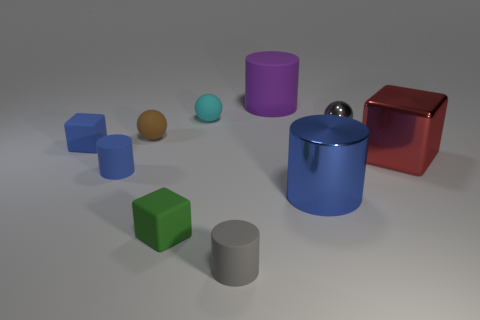What number of shiny things are brown objects or green things?
Provide a short and direct response. 0. There is a block in front of the object that is on the right side of the shiny sphere; what is it made of?
Provide a succinct answer. Rubber. Are there more purple cylinders behind the large red cube than green metallic cylinders?
Keep it short and to the point. Yes. Are there any purple cylinders that have the same material as the cyan thing?
Offer a very short reply. Yes. Is the shape of the large object that is behind the tiny blue block the same as  the small gray metallic thing?
Keep it short and to the point. No. There is a blue thing that is right of the tiny cylinder that is left of the small green cube; how many tiny matte cylinders are behind it?
Provide a short and direct response. 1. Is the number of tiny metallic things on the left side of the red cube less than the number of small cyan balls left of the gray metallic object?
Offer a terse response. No. The other large matte thing that is the same shape as the large blue object is what color?
Keep it short and to the point. Purple. The red shiny cube is what size?
Offer a very short reply. Large. How many blue metal things have the same size as the red metal block?
Provide a succinct answer. 1. 